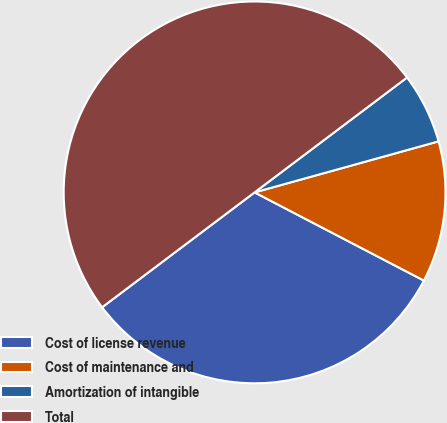Convert chart to OTSL. <chart><loc_0><loc_0><loc_500><loc_500><pie_chart><fcel>Cost of license revenue<fcel>Cost of maintenance and<fcel>Amortization of intangible<fcel>Total<nl><fcel>32.08%<fcel>11.95%<fcel>5.97%<fcel>50.0%<nl></chart> 